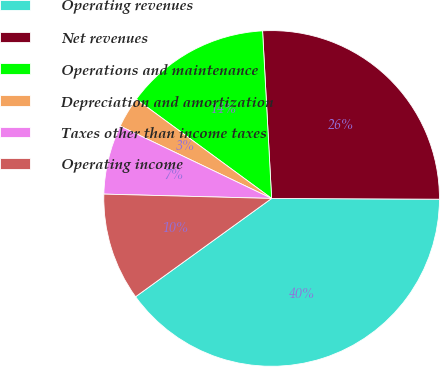<chart> <loc_0><loc_0><loc_500><loc_500><pie_chart><fcel>Operating revenues<fcel>Net revenues<fcel>Operations and maintenance<fcel>Depreciation and amortization<fcel>Taxes other than income taxes<fcel>Operating income<nl><fcel>39.97%<fcel>25.93%<fcel>14.07%<fcel>2.98%<fcel>6.68%<fcel>10.37%<nl></chart> 